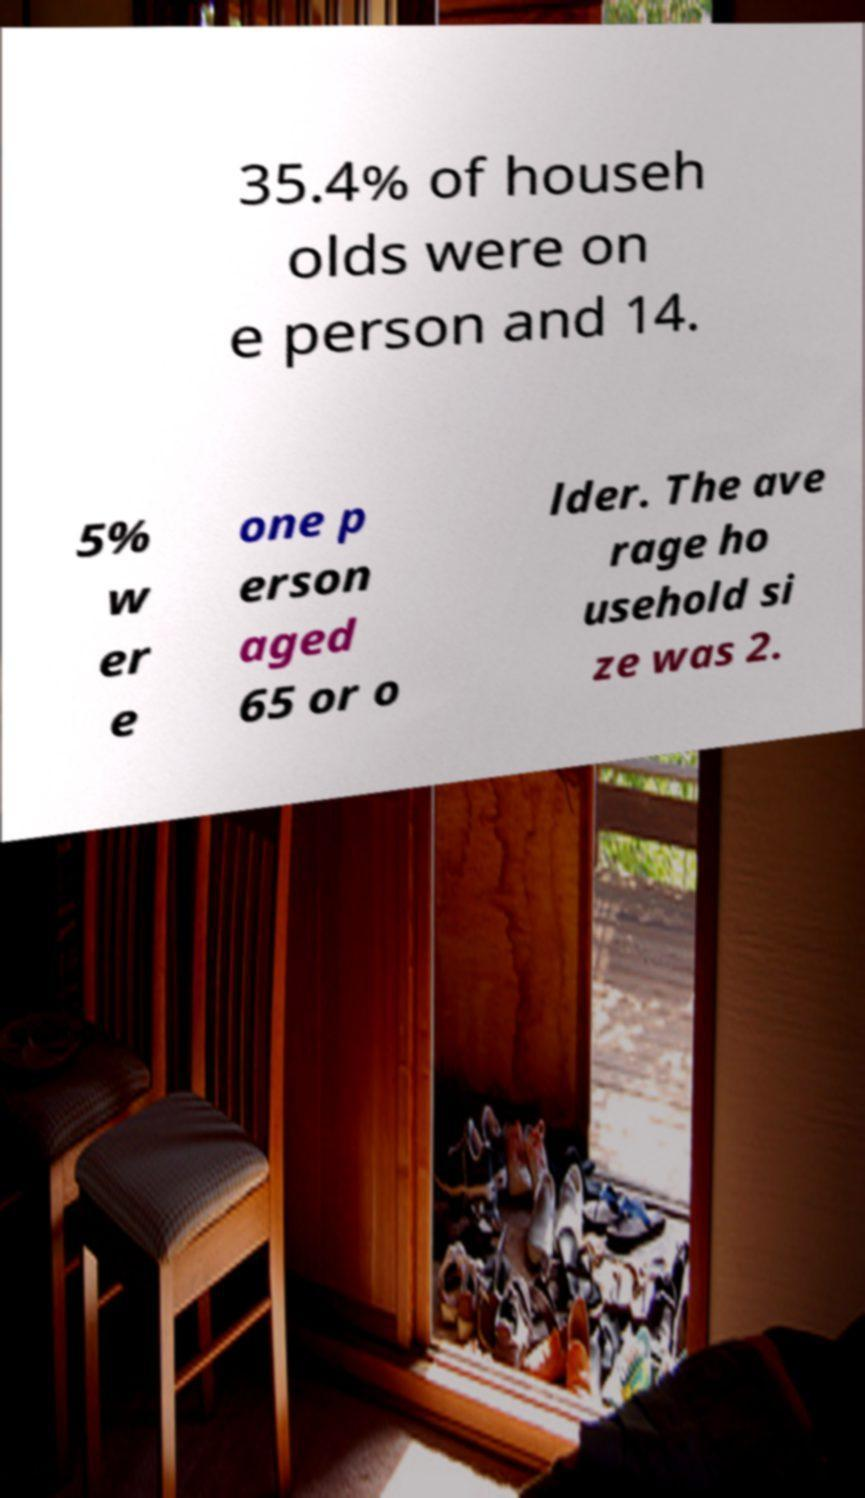Can you read and provide the text displayed in the image?This photo seems to have some interesting text. Can you extract and type it out for me? 35.4% of househ olds were on e person and 14. 5% w er e one p erson aged 65 or o lder. The ave rage ho usehold si ze was 2. 